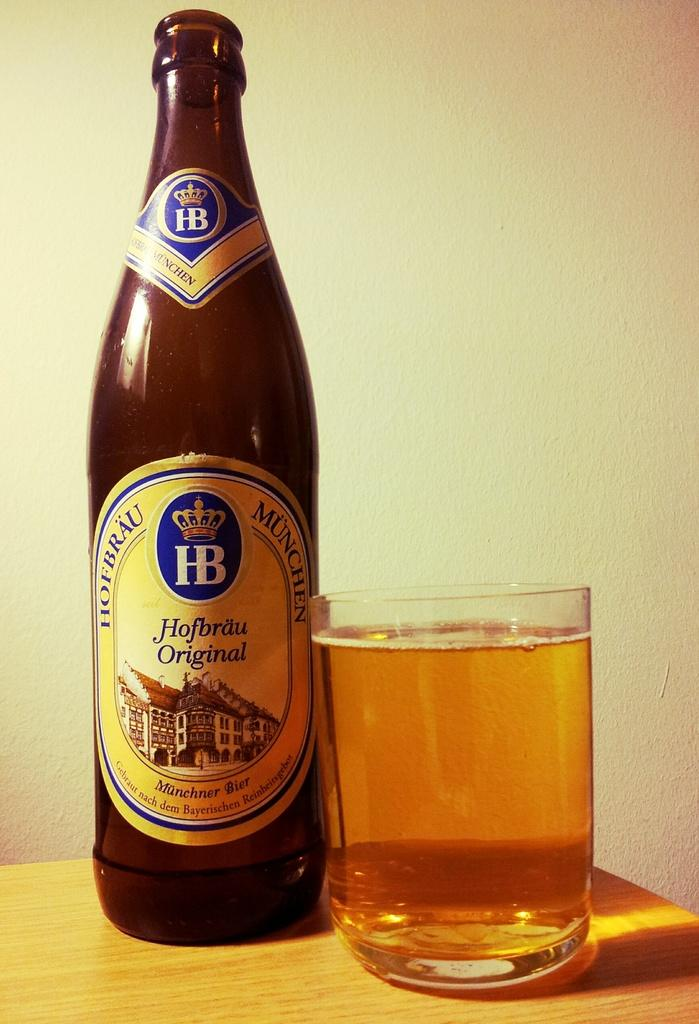<image>
Describe the image concisely. Hofbrau Original beer bottle next to a full cup of beer. 